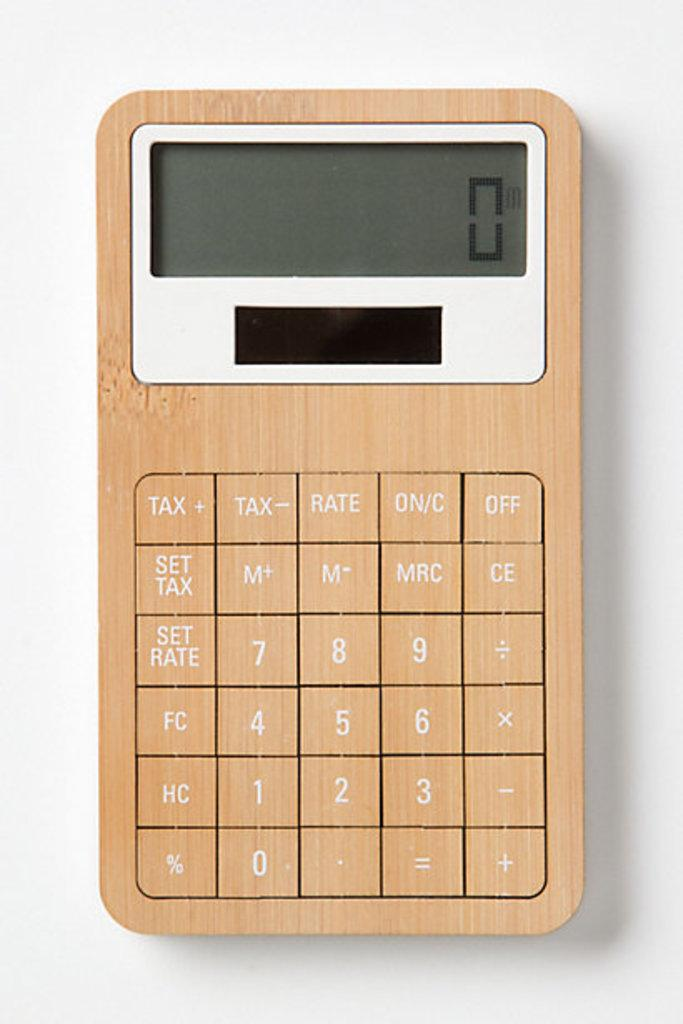<image>
Create a compact narrative representing the image presented. The calculator has special function buttons for tax calculations. 